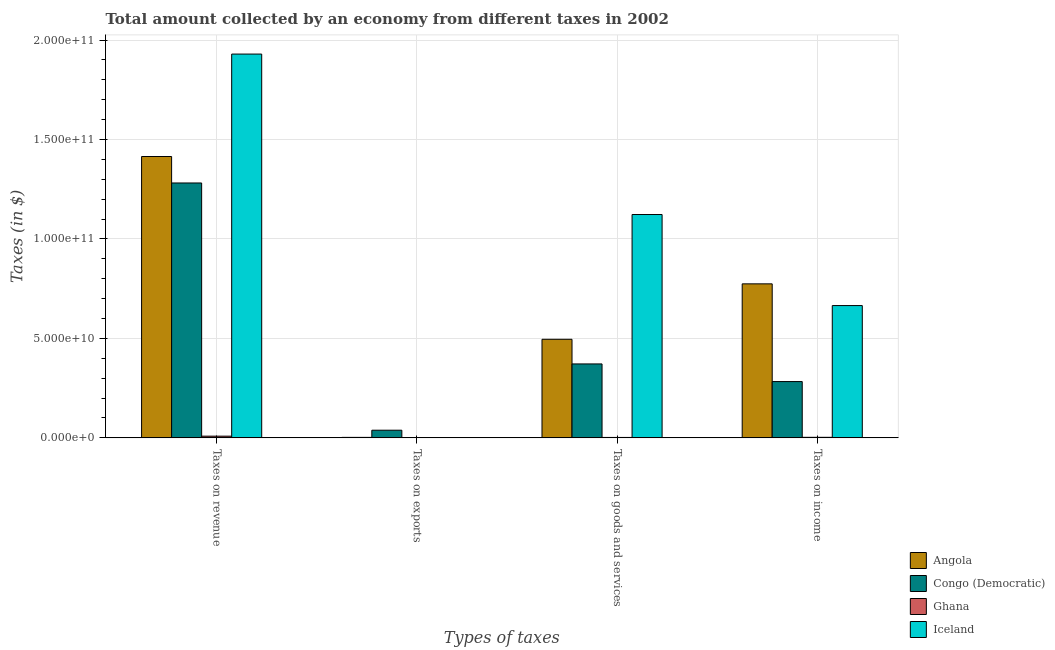How many different coloured bars are there?
Provide a succinct answer. 4. Are the number of bars on each tick of the X-axis equal?
Make the answer very short. Yes. What is the label of the 4th group of bars from the left?
Provide a short and direct response. Taxes on income. What is the amount collected as tax on goods in Iceland?
Offer a very short reply. 1.12e+11. Across all countries, what is the maximum amount collected as tax on exports?
Your answer should be compact. 3.85e+09. Across all countries, what is the minimum amount collected as tax on goods?
Keep it short and to the point. 2.16e+08. What is the total amount collected as tax on exports in the graph?
Ensure brevity in your answer.  4.13e+09. What is the difference between the amount collected as tax on income in Ghana and that in Congo (Democratic)?
Your response must be concise. -2.80e+1. What is the difference between the amount collected as tax on goods in Angola and the amount collected as tax on income in Iceland?
Provide a succinct answer. -1.70e+1. What is the average amount collected as tax on exports per country?
Offer a very short reply. 1.03e+09. What is the difference between the amount collected as tax on goods and amount collected as tax on revenue in Ghana?
Provide a short and direct response. -6.39e+08. What is the ratio of the amount collected as tax on income in Ghana to that in Iceland?
Make the answer very short. 0. What is the difference between the highest and the second highest amount collected as tax on exports?
Ensure brevity in your answer.  3.60e+09. What is the difference between the highest and the lowest amount collected as tax on income?
Ensure brevity in your answer.  7.72e+1. In how many countries, is the amount collected as tax on income greater than the average amount collected as tax on income taken over all countries?
Provide a succinct answer. 2. Is the sum of the amount collected as tax on income in Congo (Democratic) and Ghana greater than the maximum amount collected as tax on revenue across all countries?
Offer a terse response. No. Is it the case that in every country, the sum of the amount collected as tax on exports and amount collected as tax on goods is greater than the sum of amount collected as tax on income and amount collected as tax on revenue?
Your response must be concise. No. What does the 2nd bar from the right in Taxes on goods and services represents?
Provide a short and direct response. Ghana. How many countries are there in the graph?
Your answer should be very brief. 4. What is the difference between two consecutive major ticks on the Y-axis?
Ensure brevity in your answer.  5.00e+1. Are the values on the major ticks of Y-axis written in scientific E-notation?
Ensure brevity in your answer.  Yes. Does the graph contain any zero values?
Provide a succinct answer. No. How are the legend labels stacked?
Provide a succinct answer. Vertical. What is the title of the graph?
Your answer should be very brief. Total amount collected by an economy from different taxes in 2002. Does "Denmark" appear as one of the legend labels in the graph?
Your response must be concise. No. What is the label or title of the X-axis?
Offer a very short reply. Types of taxes. What is the label or title of the Y-axis?
Provide a succinct answer. Taxes (in $). What is the Taxes (in $) of Angola in Taxes on revenue?
Offer a terse response. 1.41e+11. What is the Taxes (in $) of Congo (Democratic) in Taxes on revenue?
Your answer should be compact. 1.28e+11. What is the Taxes (in $) of Ghana in Taxes on revenue?
Keep it short and to the point. 8.55e+08. What is the Taxes (in $) in Iceland in Taxes on revenue?
Offer a very short reply. 1.93e+11. What is the Taxes (in $) in Angola in Taxes on exports?
Provide a succinct answer. 2.48e+08. What is the Taxes (in $) in Congo (Democratic) in Taxes on exports?
Provide a succinct answer. 3.85e+09. What is the Taxes (in $) of Ghana in Taxes on exports?
Offer a terse response. 3.69e+07. What is the Taxes (in $) in Iceland in Taxes on exports?
Make the answer very short. 6.36e+05. What is the Taxes (in $) in Angola in Taxes on goods and services?
Ensure brevity in your answer.  4.96e+1. What is the Taxes (in $) in Congo (Democratic) in Taxes on goods and services?
Offer a very short reply. 3.72e+1. What is the Taxes (in $) in Ghana in Taxes on goods and services?
Ensure brevity in your answer.  2.16e+08. What is the Taxes (in $) in Iceland in Taxes on goods and services?
Your answer should be very brief. 1.12e+11. What is the Taxes (in $) of Angola in Taxes on income?
Your answer should be compact. 7.74e+1. What is the Taxes (in $) of Congo (Democratic) in Taxes on income?
Your response must be concise. 2.83e+1. What is the Taxes (in $) in Ghana in Taxes on income?
Your answer should be compact. 2.80e+08. What is the Taxes (in $) of Iceland in Taxes on income?
Your response must be concise. 6.65e+1. Across all Types of taxes, what is the maximum Taxes (in $) of Angola?
Give a very brief answer. 1.41e+11. Across all Types of taxes, what is the maximum Taxes (in $) in Congo (Democratic)?
Ensure brevity in your answer.  1.28e+11. Across all Types of taxes, what is the maximum Taxes (in $) of Ghana?
Give a very brief answer. 8.55e+08. Across all Types of taxes, what is the maximum Taxes (in $) in Iceland?
Your answer should be very brief. 1.93e+11. Across all Types of taxes, what is the minimum Taxes (in $) in Angola?
Provide a short and direct response. 2.48e+08. Across all Types of taxes, what is the minimum Taxes (in $) of Congo (Democratic)?
Offer a very short reply. 3.85e+09. Across all Types of taxes, what is the minimum Taxes (in $) of Ghana?
Make the answer very short. 3.69e+07. Across all Types of taxes, what is the minimum Taxes (in $) in Iceland?
Make the answer very short. 6.36e+05. What is the total Taxes (in $) of Angola in the graph?
Provide a succinct answer. 2.69e+11. What is the total Taxes (in $) in Congo (Democratic) in the graph?
Provide a succinct answer. 1.97e+11. What is the total Taxes (in $) of Ghana in the graph?
Your answer should be very brief. 1.39e+09. What is the total Taxes (in $) of Iceland in the graph?
Offer a terse response. 3.72e+11. What is the difference between the Taxes (in $) of Angola in Taxes on revenue and that in Taxes on exports?
Provide a short and direct response. 1.41e+11. What is the difference between the Taxes (in $) of Congo (Democratic) in Taxes on revenue and that in Taxes on exports?
Offer a very short reply. 1.24e+11. What is the difference between the Taxes (in $) of Ghana in Taxes on revenue and that in Taxes on exports?
Your response must be concise. 8.18e+08. What is the difference between the Taxes (in $) of Iceland in Taxes on revenue and that in Taxes on exports?
Ensure brevity in your answer.  1.93e+11. What is the difference between the Taxes (in $) of Angola in Taxes on revenue and that in Taxes on goods and services?
Keep it short and to the point. 9.19e+1. What is the difference between the Taxes (in $) of Congo (Democratic) in Taxes on revenue and that in Taxes on goods and services?
Your answer should be compact. 9.10e+1. What is the difference between the Taxes (in $) in Ghana in Taxes on revenue and that in Taxes on goods and services?
Keep it short and to the point. 6.39e+08. What is the difference between the Taxes (in $) of Iceland in Taxes on revenue and that in Taxes on goods and services?
Ensure brevity in your answer.  8.07e+1. What is the difference between the Taxes (in $) in Angola in Taxes on revenue and that in Taxes on income?
Provide a short and direct response. 6.40e+1. What is the difference between the Taxes (in $) of Congo (Democratic) in Taxes on revenue and that in Taxes on income?
Offer a terse response. 9.99e+1. What is the difference between the Taxes (in $) of Ghana in Taxes on revenue and that in Taxes on income?
Your answer should be very brief. 5.75e+08. What is the difference between the Taxes (in $) in Iceland in Taxes on revenue and that in Taxes on income?
Offer a very short reply. 1.26e+11. What is the difference between the Taxes (in $) in Angola in Taxes on exports and that in Taxes on goods and services?
Offer a very short reply. -4.93e+1. What is the difference between the Taxes (in $) of Congo (Democratic) in Taxes on exports and that in Taxes on goods and services?
Provide a succinct answer. -3.33e+1. What is the difference between the Taxes (in $) of Ghana in Taxes on exports and that in Taxes on goods and services?
Your answer should be compact. -1.79e+08. What is the difference between the Taxes (in $) in Iceland in Taxes on exports and that in Taxes on goods and services?
Give a very brief answer. -1.12e+11. What is the difference between the Taxes (in $) in Angola in Taxes on exports and that in Taxes on income?
Ensure brevity in your answer.  -7.72e+1. What is the difference between the Taxes (in $) in Congo (Democratic) in Taxes on exports and that in Taxes on income?
Give a very brief answer. -2.45e+1. What is the difference between the Taxes (in $) in Ghana in Taxes on exports and that in Taxes on income?
Your answer should be very brief. -2.43e+08. What is the difference between the Taxes (in $) of Iceland in Taxes on exports and that in Taxes on income?
Make the answer very short. -6.65e+1. What is the difference between the Taxes (in $) in Angola in Taxes on goods and services and that in Taxes on income?
Provide a succinct answer. -2.79e+1. What is the difference between the Taxes (in $) of Congo (Democratic) in Taxes on goods and services and that in Taxes on income?
Your answer should be very brief. 8.87e+09. What is the difference between the Taxes (in $) of Ghana in Taxes on goods and services and that in Taxes on income?
Make the answer very short. -6.37e+07. What is the difference between the Taxes (in $) of Iceland in Taxes on goods and services and that in Taxes on income?
Your response must be concise. 4.58e+1. What is the difference between the Taxes (in $) in Angola in Taxes on revenue and the Taxes (in $) in Congo (Democratic) in Taxes on exports?
Your answer should be compact. 1.38e+11. What is the difference between the Taxes (in $) of Angola in Taxes on revenue and the Taxes (in $) of Ghana in Taxes on exports?
Offer a terse response. 1.41e+11. What is the difference between the Taxes (in $) of Angola in Taxes on revenue and the Taxes (in $) of Iceland in Taxes on exports?
Provide a succinct answer. 1.41e+11. What is the difference between the Taxes (in $) in Congo (Democratic) in Taxes on revenue and the Taxes (in $) in Ghana in Taxes on exports?
Your answer should be very brief. 1.28e+11. What is the difference between the Taxes (in $) of Congo (Democratic) in Taxes on revenue and the Taxes (in $) of Iceland in Taxes on exports?
Give a very brief answer. 1.28e+11. What is the difference between the Taxes (in $) of Ghana in Taxes on revenue and the Taxes (in $) of Iceland in Taxes on exports?
Offer a very short reply. 8.54e+08. What is the difference between the Taxes (in $) in Angola in Taxes on revenue and the Taxes (in $) in Congo (Democratic) in Taxes on goods and services?
Keep it short and to the point. 1.04e+11. What is the difference between the Taxes (in $) in Angola in Taxes on revenue and the Taxes (in $) in Ghana in Taxes on goods and services?
Your answer should be very brief. 1.41e+11. What is the difference between the Taxes (in $) in Angola in Taxes on revenue and the Taxes (in $) in Iceland in Taxes on goods and services?
Give a very brief answer. 2.92e+1. What is the difference between the Taxes (in $) in Congo (Democratic) in Taxes on revenue and the Taxes (in $) in Ghana in Taxes on goods and services?
Your answer should be compact. 1.28e+11. What is the difference between the Taxes (in $) of Congo (Democratic) in Taxes on revenue and the Taxes (in $) of Iceland in Taxes on goods and services?
Give a very brief answer. 1.59e+1. What is the difference between the Taxes (in $) in Ghana in Taxes on revenue and the Taxes (in $) in Iceland in Taxes on goods and services?
Keep it short and to the point. -1.11e+11. What is the difference between the Taxes (in $) in Angola in Taxes on revenue and the Taxes (in $) in Congo (Democratic) in Taxes on income?
Ensure brevity in your answer.  1.13e+11. What is the difference between the Taxes (in $) in Angola in Taxes on revenue and the Taxes (in $) in Ghana in Taxes on income?
Ensure brevity in your answer.  1.41e+11. What is the difference between the Taxes (in $) in Angola in Taxes on revenue and the Taxes (in $) in Iceland in Taxes on income?
Keep it short and to the point. 7.50e+1. What is the difference between the Taxes (in $) in Congo (Democratic) in Taxes on revenue and the Taxes (in $) in Ghana in Taxes on income?
Your response must be concise. 1.28e+11. What is the difference between the Taxes (in $) of Congo (Democratic) in Taxes on revenue and the Taxes (in $) of Iceland in Taxes on income?
Give a very brief answer. 6.16e+1. What is the difference between the Taxes (in $) of Ghana in Taxes on revenue and the Taxes (in $) of Iceland in Taxes on income?
Offer a terse response. -6.57e+1. What is the difference between the Taxes (in $) in Angola in Taxes on exports and the Taxes (in $) in Congo (Democratic) in Taxes on goods and services?
Keep it short and to the point. -3.69e+1. What is the difference between the Taxes (in $) of Angola in Taxes on exports and the Taxes (in $) of Ghana in Taxes on goods and services?
Offer a terse response. 3.23e+07. What is the difference between the Taxes (in $) of Angola in Taxes on exports and the Taxes (in $) of Iceland in Taxes on goods and services?
Offer a very short reply. -1.12e+11. What is the difference between the Taxes (in $) in Congo (Democratic) in Taxes on exports and the Taxes (in $) in Ghana in Taxes on goods and services?
Your response must be concise. 3.63e+09. What is the difference between the Taxes (in $) in Congo (Democratic) in Taxes on exports and the Taxes (in $) in Iceland in Taxes on goods and services?
Offer a very short reply. -1.08e+11. What is the difference between the Taxes (in $) of Ghana in Taxes on exports and the Taxes (in $) of Iceland in Taxes on goods and services?
Your response must be concise. -1.12e+11. What is the difference between the Taxes (in $) in Angola in Taxes on exports and the Taxes (in $) in Congo (Democratic) in Taxes on income?
Ensure brevity in your answer.  -2.81e+1. What is the difference between the Taxes (in $) in Angola in Taxes on exports and the Taxes (in $) in Ghana in Taxes on income?
Provide a succinct answer. -3.14e+07. What is the difference between the Taxes (in $) in Angola in Taxes on exports and the Taxes (in $) in Iceland in Taxes on income?
Offer a terse response. -6.63e+1. What is the difference between the Taxes (in $) in Congo (Democratic) in Taxes on exports and the Taxes (in $) in Ghana in Taxes on income?
Your answer should be very brief. 3.57e+09. What is the difference between the Taxes (in $) in Congo (Democratic) in Taxes on exports and the Taxes (in $) in Iceland in Taxes on income?
Make the answer very short. -6.27e+1. What is the difference between the Taxes (in $) of Ghana in Taxes on exports and the Taxes (in $) of Iceland in Taxes on income?
Provide a succinct answer. -6.65e+1. What is the difference between the Taxes (in $) in Angola in Taxes on goods and services and the Taxes (in $) in Congo (Democratic) in Taxes on income?
Make the answer very short. 2.13e+1. What is the difference between the Taxes (in $) of Angola in Taxes on goods and services and the Taxes (in $) of Ghana in Taxes on income?
Your answer should be compact. 4.93e+1. What is the difference between the Taxes (in $) in Angola in Taxes on goods and services and the Taxes (in $) in Iceland in Taxes on income?
Keep it short and to the point. -1.70e+1. What is the difference between the Taxes (in $) of Congo (Democratic) in Taxes on goods and services and the Taxes (in $) of Ghana in Taxes on income?
Keep it short and to the point. 3.69e+1. What is the difference between the Taxes (in $) of Congo (Democratic) in Taxes on goods and services and the Taxes (in $) of Iceland in Taxes on income?
Make the answer very short. -2.93e+1. What is the difference between the Taxes (in $) of Ghana in Taxes on goods and services and the Taxes (in $) of Iceland in Taxes on income?
Offer a very short reply. -6.63e+1. What is the average Taxes (in $) of Angola per Types of taxes?
Your response must be concise. 6.72e+1. What is the average Taxes (in $) of Congo (Democratic) per Types of taxes?
Make the answer very short. 4.94e+1. What is the average Taxes (in $) in Ghana per Types of taxes?
Provide a short and direct response. 3.47e+08. What is the average Taxes (in $) in Iceland per Types of taxes?
Offer a terse response. 9.29e+1. What is the difference between the Taxes (in $) of Angola and Taxes (in $) of Congo (Democratic) in Taxes on revenue?
Provide a short and direct response. 1.33e+1. What is the difference between the Taxes (in $) of Angola and Taxes (in $) of Ghana in Taxes on revenue?
Make the answer very short. 1.41e+11. What is the difference between the Taxes (in $) of Angola and Taxes (in $) of Iceland in Taxes on revenue?
Make the answer very short. -5.15e+1. What is the difference between the Taxes (in $) in Congo (Democratic) and Taxes (in $) in Ghana in Taxes on revenue?
Ensure brevity in your answer.  1.27e+11. What is the difference between the Taxes (in $) in Congo (Democratic) and Taxes (in $) in Iceland in Taxes on revenue?
Ensure brevity in your answer.  -6.48e+1. What is the difference between the Taxes (in $) in Ghana and Taxes (in $) in Iceland in Taxes on revenue?
Offer a very short reply. -1.92e+11. What is the difference between the Taxes (in $) of Angola and Taxes (in $) of Congo (Democratic) in Taxes on exports?
Give a very brief answer. -3.60e+09. What is the difference between the Taxes (in $) in Angola and Taxes (in $) in Ghana in Taxes on exports?
Your response must be concise. 2.11e+08. What is the difference between the Taxes (in $) of Angola and Taxes (in $) of Iceland in Taxes on exports?
Give a very brief answer. 2.48e+08. What is the difference between the Taxes (in $) in Congo (Democratic) and Taxes (in $) in Ghana in Taxes on exports?
Provide a succinct answer. 3.81e+09. What is the difference between the Taxes (in $) in Congo (Democratic) and Taxes (in $) in Iceland in Taxes on exports?
Provide a succinct answer. 3.85e+09. What is the difference between the Taxes (in $) in Ghana and Taxes (in $) in Iceland in Taxes on exports?
Offer a very short reply. 3.62e+07. What is the difference between the Taxes (in $) in Angola and Taxes (in $) in Congo (Democratic) in Taxes on goods and services?
Ensure brevity in your answer.  1.24e+1. What is the difference between the Taxes (in $) in Angola and Taxes (in $) in Ghana in Taxes on goods and services?
Offer a terse response. 4.93e+1. What is the difference between the Taxes (in $) of Angola and Taxes (in $) of Iceland in Taxes on goods and services?
Give a very brief answer. -6.27e+1. What is the difference between the Taxes (in $) of Congo (Democratic) and Taxes (in $) of Ghana in Taxes on goods and services?
Your answer should be very brief. 3.70e+1. What is the difference between the Taxes (in $) of Congo (Democratic) and Taxes (in $) of Iceland in Taxes on goods and services?
Offer a very short reply. -7.51e+1. What is the difference between the Taxes (in $) of Ghana and Taxes (in $) of Iceland in Taxes on goods and services?
Offer a terse response. -1.12e+11. What is the difference between the Taxes (in $) of Angola and Taxes (in $) of Congo (Democratic) in Taxes on income?
Provide a succinct answer. 4.91e+1. What is the difference between the Taxes (in $) in Angola and Taxes (in $) in Ghana in Taxes on income?
Your answer should be very brief. 7.72e+1. What is the difference between the Taxes (in $) in Angola and Taxes (in $) in Iceland in Taxes on income?
Keep it short and to the point. 1.09e+1. What is the difference between the Taxes (in $) in Congo (Democratic) and Taxes (in $) in Ghana in Taxes on income?
Offer a very short reply. 2.80e+1. What is the difference between the Taxes (in $) in Congo (Democratic) and Taxes (in $) in Iceland in Taxes on income?
Offer a terse response. -3.82e+1. What is the difference between the Taxes (in $) of Ghana and Taxes (in $) of Iceland in Taxes on income?
Your response must be concise. -6.62e+1. What is the ratio of the Taxes (in $) of Angola in Taxes on revenue to that in Taxes on exports?
Your answer should be compact. 570.12. What is the ratio of the Taxes (in $) in Congo (Democratic) in Taxes on revenue to that in Taxes on exports?
Keep it short and to the point. 33.31. What is the ratio of the Taxes (in $) of Ghana in Taxes on revenue to that in Taxes on exports?
Your response must be concise. 23.17. What is the ratio of the Taxes (in $) in Iceland in Taxes on revenue to that in Taxes on exports?
Ensure brevity in your answer.  3.03e+05. What is the ratio of the Taxes (in $) of Angola in Taxes on revenue to that in Taxes on goods and services?
Your answer should be compact. 2.85. What is the ratio of the Taxes (in $) in Congo (Democratic) in Taxes on revenue to that in Taxes on goods and services?
Offer a terse response. 3.45. What is the ratio of the Taxes (in $) in Ghana in Taxes on revenue to that in Taxes on goods and services?
Your answer should be compact. 3.96. What is the ratio of the Taxes (in $) in Iceland in Taxes on revenue to that in Taxes on goods and services?
Your response must be concise. 1.72. What is the ratio of the Taxes (in $) in Angola in Taxes on revenue to that in Taxes on income?
Make the answer very short. 1.83. What is the ratio of the Taxes (in $) in Congo (Democratic) in Taxes on revenue to that in Taxes on income?
Provide a succinct answer. 4.53. What is the ratio of the Taxes (in $) of Ghana in Taxes on revenue to that in Taxes on income?
Ensure brevity in your answer.  3.06. What is the ratio of the Taxes (in $) in Iceland in Taxes on revenue to that in Taxes on income?
Provide a succinct answer. 2.9. What is the ratio of the Taxes (in $) in Angola in Taxes on exports to that in Taxes on goods and services?
Provide a short and direct response. 0.01. What is the ratio of the Taxes (in $) of Congo (Democratic) in Taxes on exports to that in Taxes on goods and services?
Your answer should be very brief. 0.1. What is the ratio of the Taxes (in $) in Ghana in Taxes on exports to that in Taxes on goods and services?
Make the answer very short. 0.17. What is the ratio of the Taxes (in $) in Iceland in Taxes on exports to that in Taxes on goods and services?
Ensure brevity in your answer.  0. What is the ratio of the Taxes (in $) of Angola in Taxes on exports to that in Taxes on income?
Offer a very short reply. 0. What is the ratio of the Taxes (in $) in Congo (Democratic) in Taxes on exports to that in Taxes on income?
Your answer should be very brief. 0.14. What is the ratio of the Taxes (in $) in Ghana in Taxes on exports to that in Taxes on income?
Provide a short and direct response. 0.13. What is the ratio of the Taxes (in $) in Angola in Taxes on goods and services to that in Taxes on income?
Your response must be concise. 0.64. What is the ratio of the Taxes (in $) in Congo (Democratic) in Taxes on goods and services to that in Taxes on income?
Offer a very short reply. 1.31. What is the ratio of the Taxes (in $) of Ghana in Taxes on goods and services to that in Taxes on income?
Ensure brevity in your answer.  0.77. What is the ratio of the Taxes (in $) of Iceland in Taxes on goods and services to that in Taxes on income?
Ensure brevity in your answer.  1.69. What is the difference between the highest and the second highest Taxes (in $) in Angola?
Your answer should be compact. 6.40e+1. What is the difference between the highest and the second highest Taxes (in $) of Congo (Democratic)?
Offer a terse response. 9.10e+1. What is the difference between the highest and the second highest Taxes (in $) in Ghana?
Provide a short and direct response. 5.75e+08. What is the difference between the highest and the second highest Taxes (in $) in Iceland?
Give a very brief answer. 8.07e+1. What is the difference between the highest and the lowest Taxes (in $) in Angola?
Keep it short and to the point. 1.41e+11. What is the difference between the highest and the lowest Taxes (in $) of Congo (Democratic)?
Provide a succinct answer. 1.24e+11. What is the difference between the highest and the lowest Taxes (in $) in Ghana?
Provide a short and direct response. 8.18e+08. What is the difference between the highest and the lowest Taxes (in $) of Iceland?
Give a very brief answer. 1.93e+11. 